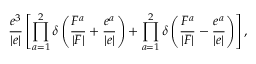<formula> <loc_0><loc_0><loc_500><loc_500>\frac { e ^ { 3 } } { | e | } \left [ \prod _ { a = 1 } ^ { 2 } \delta \left ( \frac { F ^ { a } } { | F | } + \frac { e ^ { a } } { | e | } \right ) + \prod _ { a = 1 } ^ { 2 } \delta \left ( \frac { F ^ { a } } { | F | } - \frac { e ^ { a } } { | e | } \right ) \right ] ,</formula> 